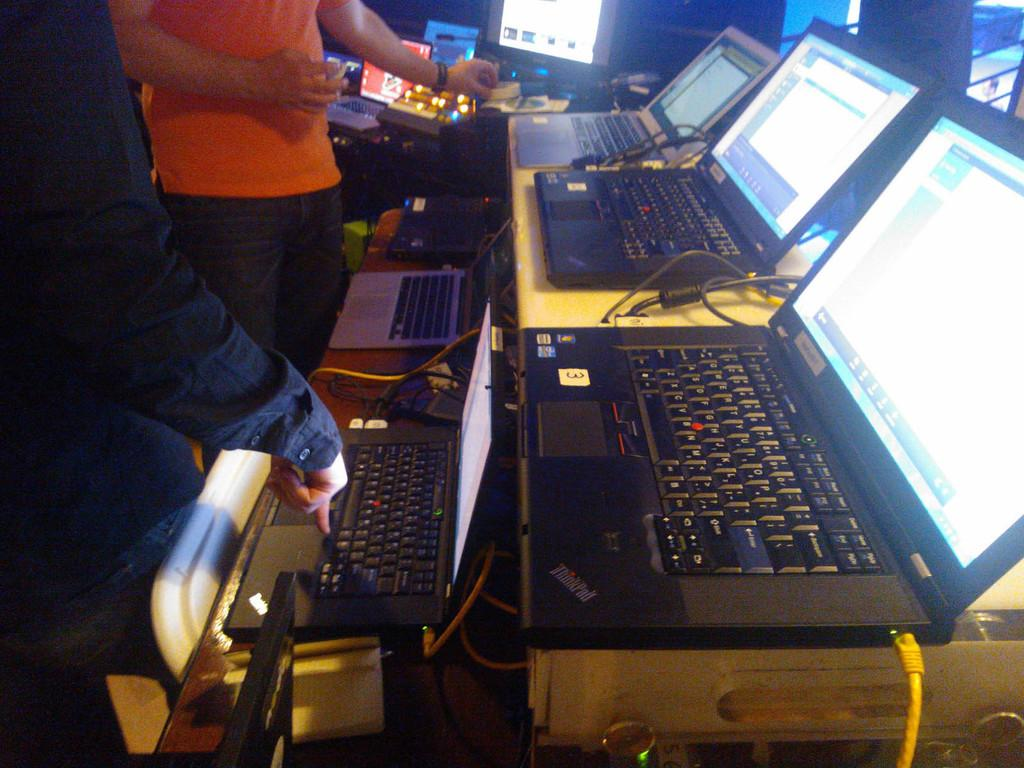<image>
Give a short and clear explanation of the subsequent image. A ThinkPad brand laptop is sitting next to many other laptops on a table. 